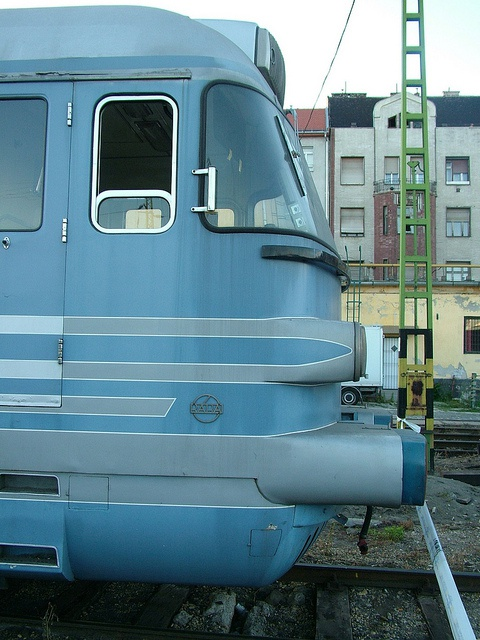Describe the objects in this image and their specific colors. I can see train in white, gray, blue, black, and teal tones and truck in white, lightblue, and black tones in this image. 